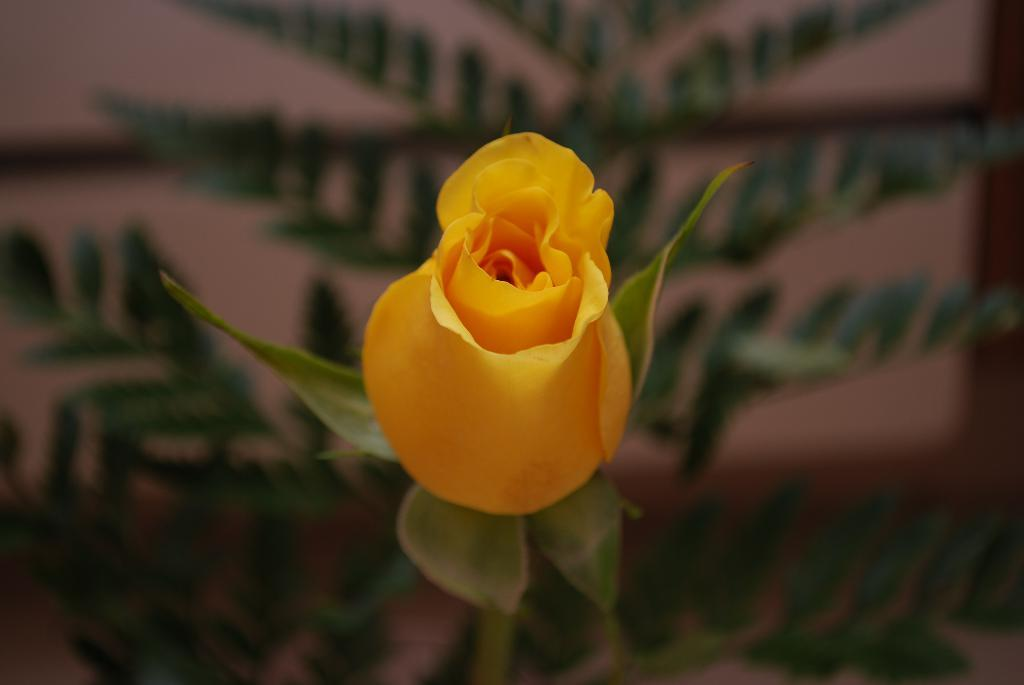What is the main subject of the picture? There is a yellow flower in the middle of the picture. Can you describe the background of the image? The background of the image is blurred. How many beads are scattered around the yellow flower in the image? There are no beads present in the image; it only features a yellow flower and a blurred background. What type of mint can be seen growing near the yellow flower in the image? There is no mint present in the image; it only features a yellow flower and a blurred background. 